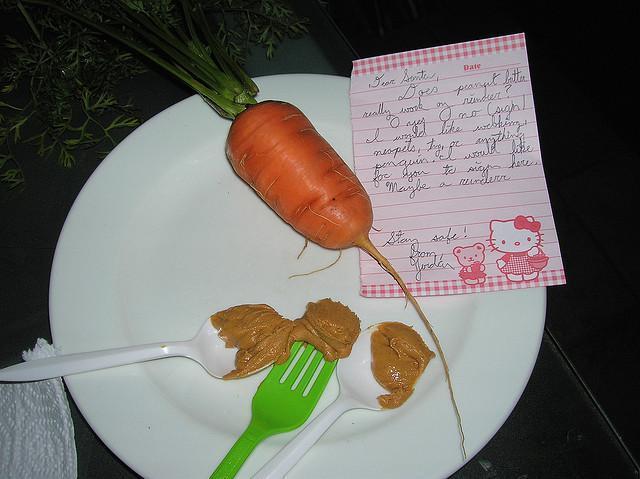How many utensils are on the plate?
Give a very brief answer. 3. How many carrots can you see?
Give a very brief answer. 1. How many spoons are there?
Give a very brief answer. 2. How many girls are in the pictures?
Give a very brief answer. 0. 